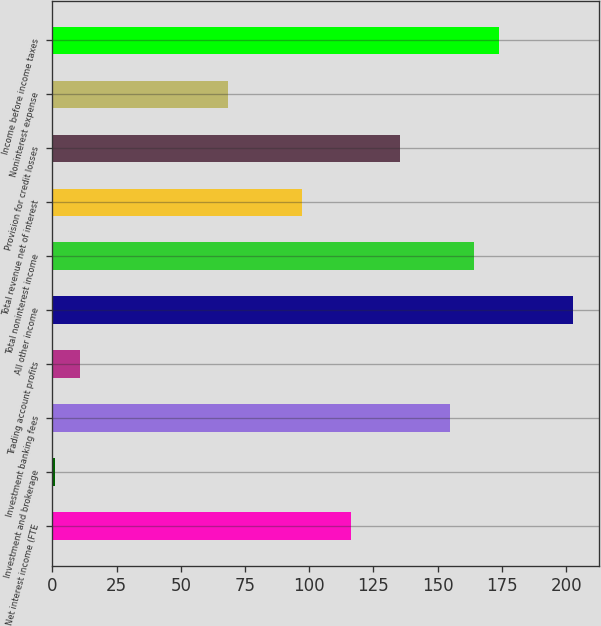<chart> <loc_0><loc_0><loc_500><loc_500><bar_chart><fcel>Net interest income (FTE<fcel>Investment and brokerage<fcel>Investment banking fees<fcel>Trading account profits<fcel>All other income<fcel>Total noninterest income<fcel>Total revenue net of interest<fcel>Provision for credit losses<fcel>Noninterest expense<fcel>Income before income taxes<nl><fcel>116.2<fcel>1<fcel>154.6<fcel>10.6<fcel>202.6<fcel>164.2<fcel>97<fcel>135.4<fcel>68.2<fcel>173.8<nl></chart> 